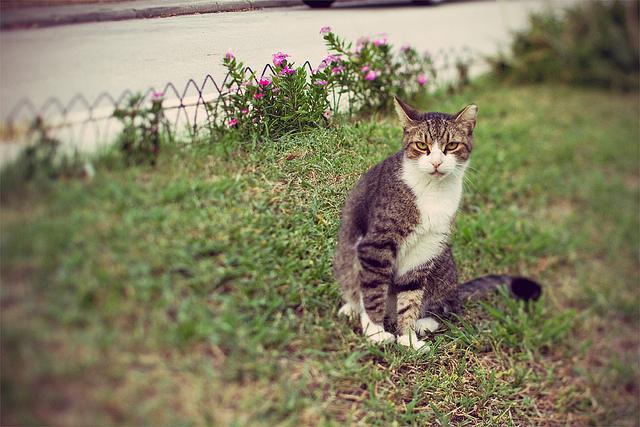What is the color of the grass?
Give a very brief answer. Green. Is this a  koala?
Be succinct. No. Is this animal a herbivore?
Be succinct. No. Is this animal confined?
Write a very short answer. No. 